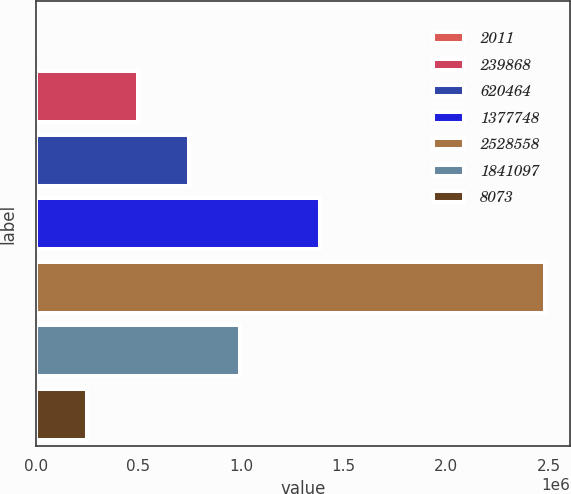Convert chart to OTSL. <chart><loc_0><loc_0><loc_500><loc_500><bar_chart><fcel>2011<fcel>239868<fcel>620464<fcel>1377748<fcel>2528558<fcel>1841097<fcel>8073<nl><fcel>2011<fcel>497603<fcel>745398<fcel>1.38704e+06<fcel>2.47997e+06<fcel>993194<fcel>249807<nl></chart> 